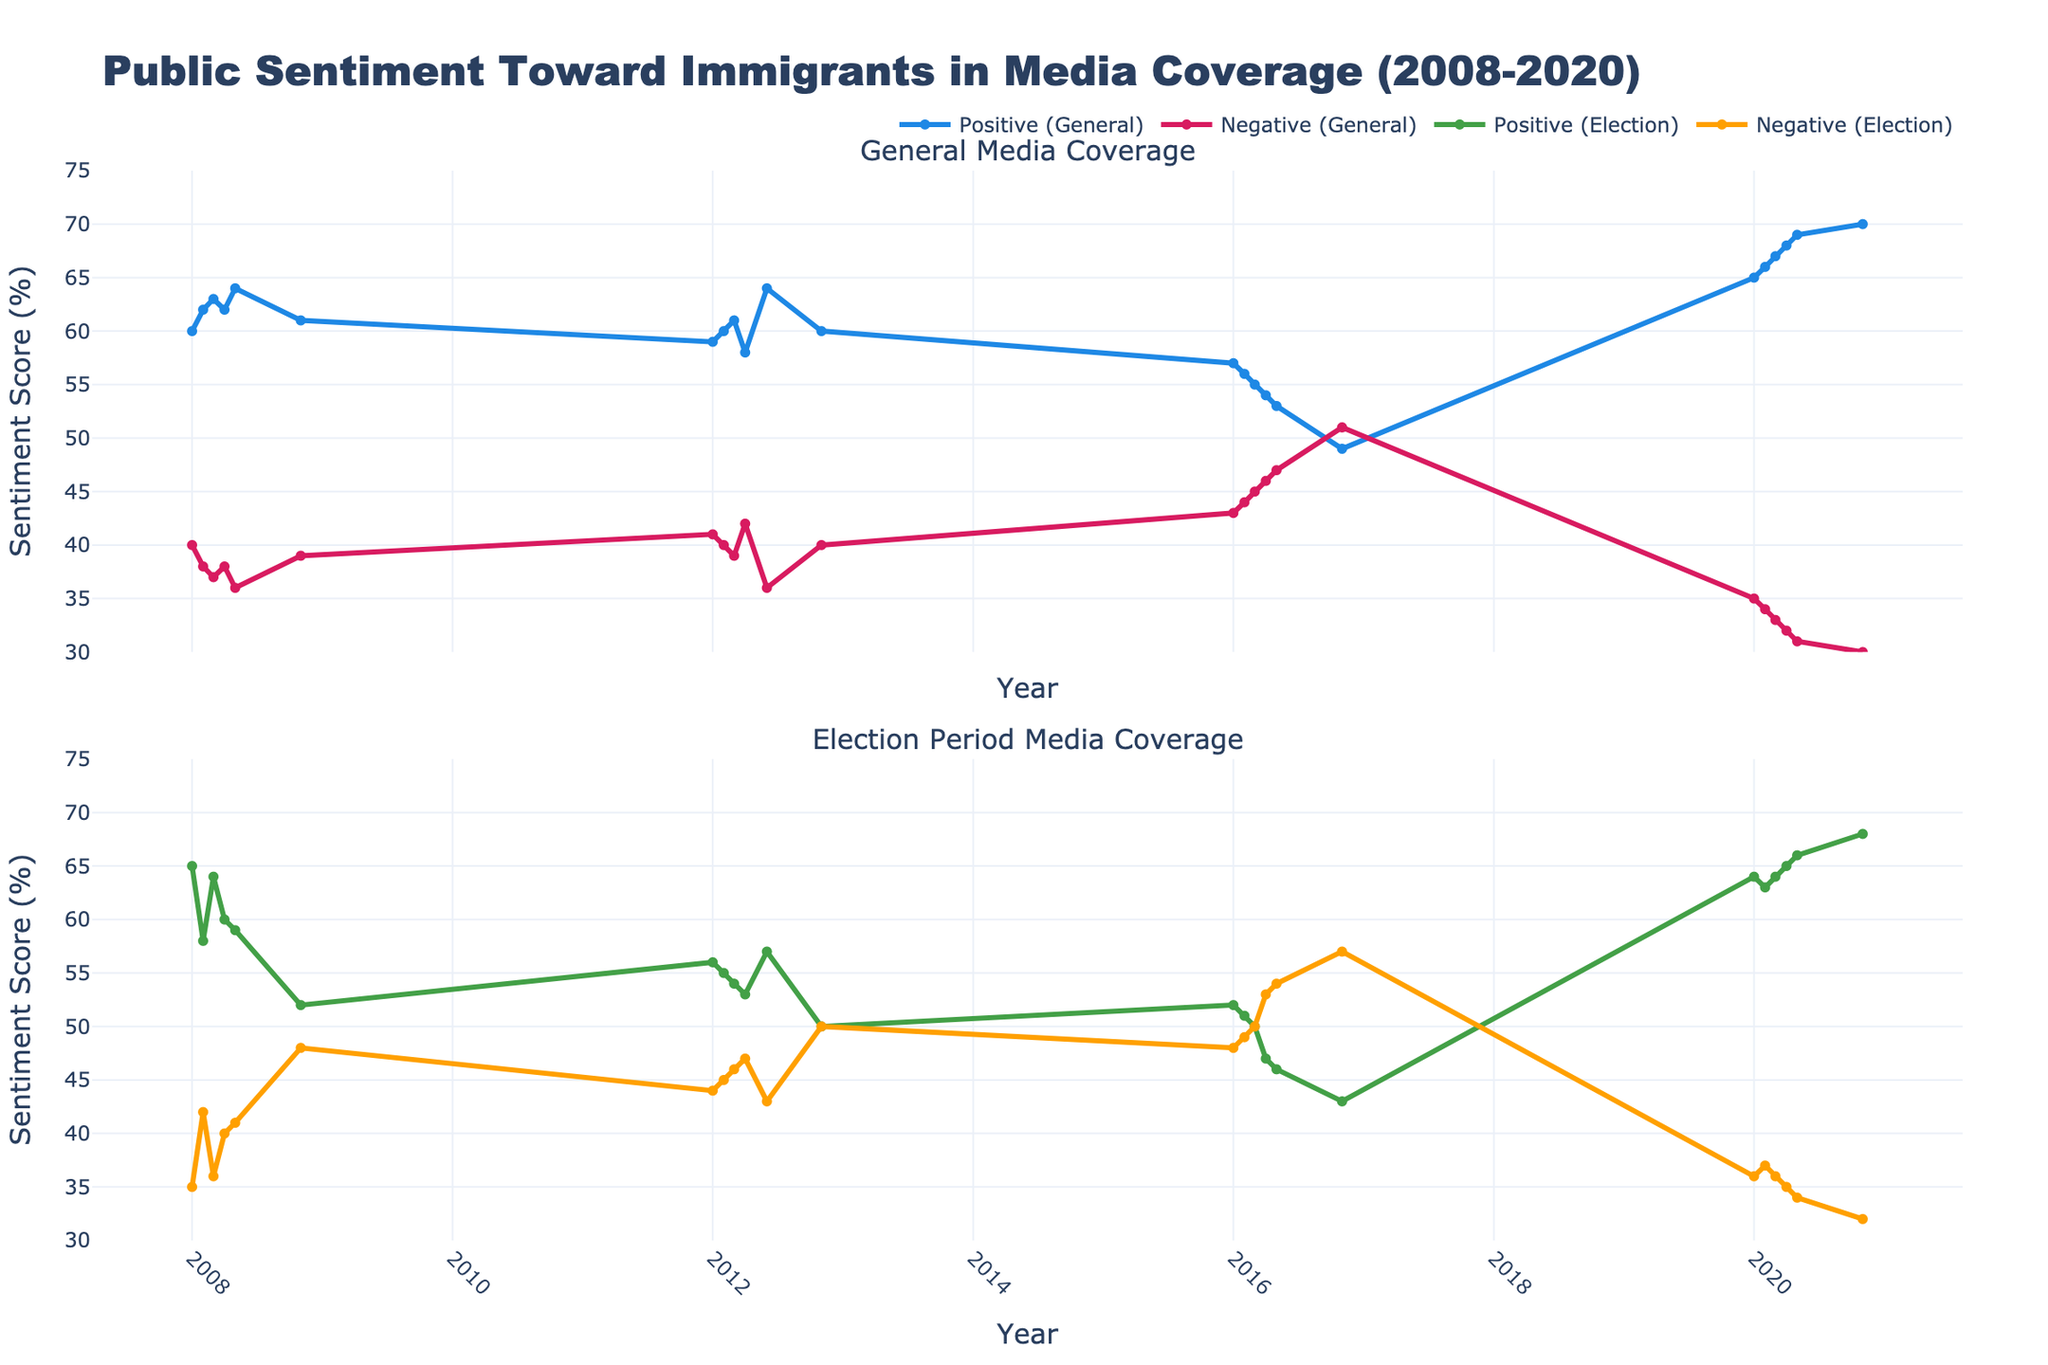What's the highest general media positive sentiment score for immigrants? To find the highest score for general media positive sentiment, look at the blue line in the first plot and identify its peak point. The highest point is in November 2020 at 70%.
Answer: 70% Which year had the lowest election media negative sentiment? To determine the lowest election media negative sentiment score, follow the yellow line in the second plot and find the lowest point. The lowest election media negative sentiment is in May 2020 at 34%.
Answer: 34% Compare the general media positive sentiment between January 2008 and January 2012. Which period had a higher sentiment score? Evaluate the blue line at the two specified points, January 2008 and January 2012. In January 2008, the score is 60%, and in January 2012, it's 59%. January 2008 had a higher score.
Answer: January 2008 What is the average positive sentiment in general media coverage over the entire period? To find this, sum up all the general media positive sentiment scores and divide by the number of data points. The data points are 60, 62, 63, 62, 64, 61, 59, 60, 61, 58, 64, 60, 57, 56, 55, 54, 53, 49, 65, 66, 67, 68, 69, 70. Summing these values gives 1376 and dividing by 24 gives the average as approximately 57.33.
Answer: 57.33% How did the general media negative sentiment change from November 2016 to November 2020? Look at the red line in the first plot at the specified points. In November 2016, the score is 51%, and in November 2020, it's 30%. The change is 51% - 30% = 21% decrease.
Answer: 21% decrease Did election media positive sentiment ever exceed general media positive sentiment? Compare the green and blue lines in both plots. Election media positive sentiment exceeds general media positive sentiment in January 2008 and March 2008.
Answer: Yes Which year saw the highest increase in general media positive sentiment within a calendar year? Compare month-to-month differences in the blue line for each year. The highest increase within the year is seen in 2020, from 65% in January to 70% in November, accounting for an increase of 5%.
Answer: 2020 On average, is the general media's sentiment typically more positive or negative? Average the positive and negative sentiments separately. Sum the positive scores (1376) and negative scores (24 data points of varying values). Positive average is approximately 57.33% (1376/24), while the negative can be computed similarly and results usually below 50%, indicating typically more positive sentiment.
Answer: More positive During which election period did the general media negative sentiment spike the most? Look for spikes in the red line in the first plot during election months (November 2008, November 2012, November 2016, November 2020). The most significant spike is in November 2016, reaching 51%.
Answer: November 2016 